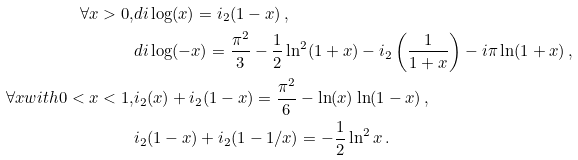<formula> <loc_0><loc_0><loc_500><loc_500>\forall x > 0 , & d i \log ( x ) = \L i _ { 2 } ( 1 - x ) \, , \\ & d i \log ( - x ) = \frac { \pi ^ { 2 } } { 3 } - \frac { 1 } { 2 } \ln ^ { 2 } ( 1 + x ) - \L i _ { 2 } \left ( \frac { 1 } { 1 + x } \right ) - i \pi \ln ( 1 + x ) \, , \\ \forall x w i t h 0 < x < 1 , & \L i _ { 2 } ( x ) + \L i _ { 2 } ( 1 - x ) = \frac { \pi ^ { 2 } } { 6 } - \ln ( x ) \ln ( 1 - x ) \, , \\ & \L i _ { 2 } ( 1 - x ) + \L i _ { 2 } ( 1 - 1 / x ) = - \frac { 1 } { 2 } \ln ^ { 2 } x \, .</formula> 